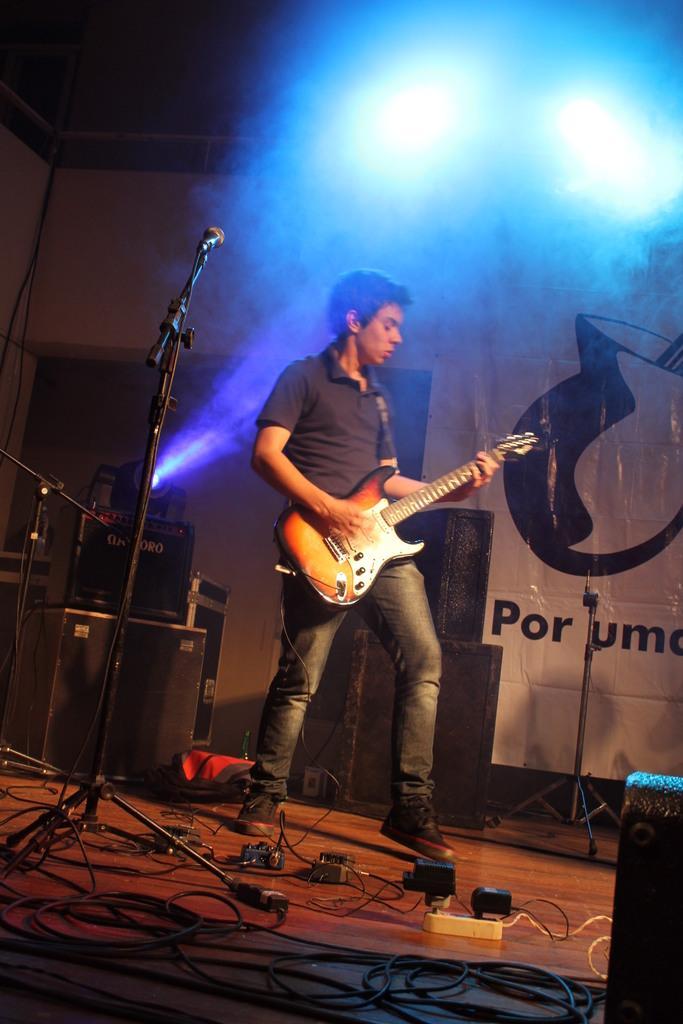In one or two sentences, can you explain what this image depicts? Here we see a man playing a guitar on the stage and we see a microphone 